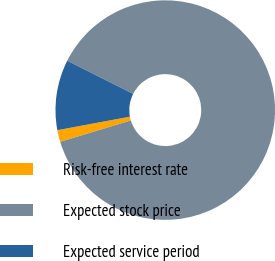<chart> <loc_0><loc_0><loc_500><loc_500><pie_chart><fcel>Risk-free interest rate<fcel>Expected stock price<fcel>Expected service period<nl><fcel>1.74%<fcel>87.91%<fcel>10.35%<nl></chart> 